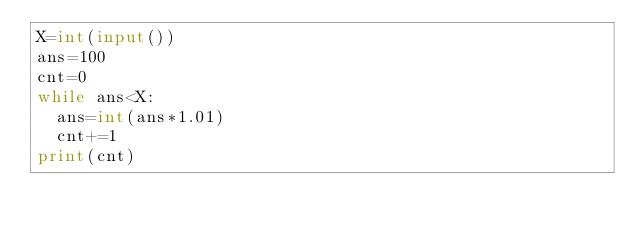Convert code to text. <code><loc_0><loc_0><loc_500><loc_500><_Python_>X=int(input())
ans=100
cnt=0
while ans<X:
  ans=int(ans*1.01)
  cnt+=1
print(cnt)</code> 